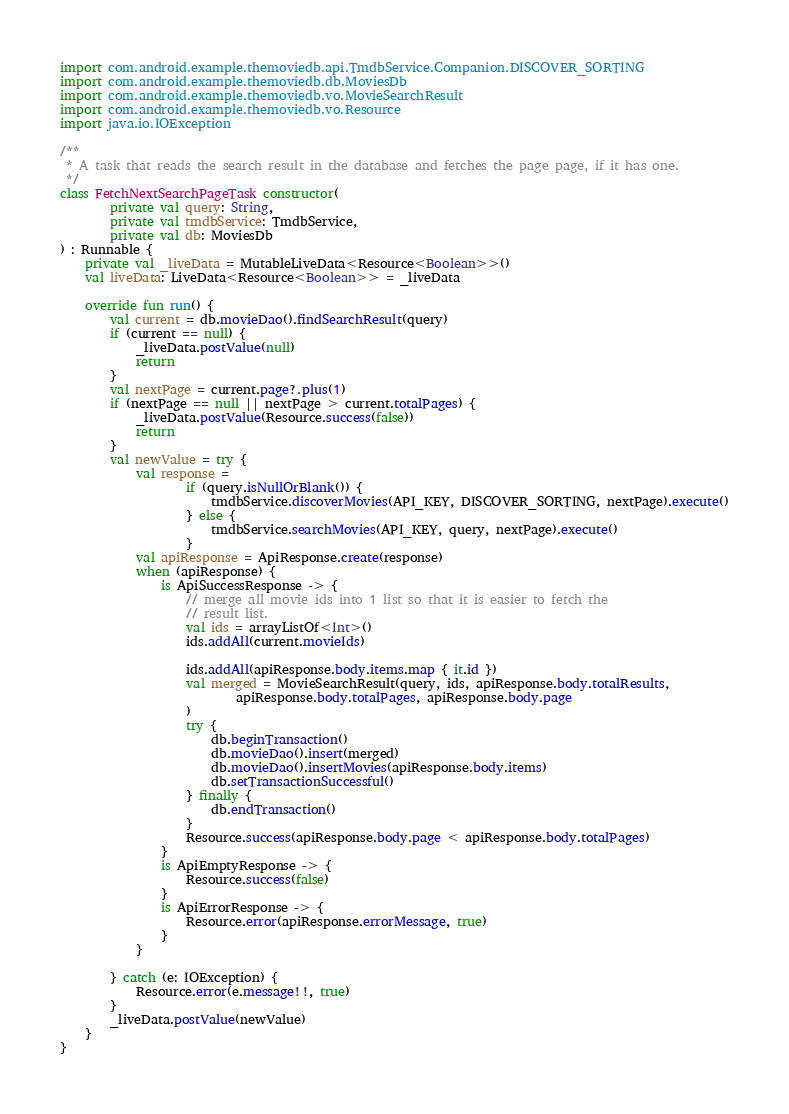Convert code to text. <code><loc_0><loc_0><loc_500><loc_500><_Kotlin_>import com.android.example.themoviedb.api.TmdbService.Companion.DISCOVER_SORTING
import com.android.example.themoviedb.db.MoviesDb
import com.android.example.themoviedb.vo.MovieSearchResult
import com.android.example.themoviedb.vo.Resource
import java.io.IOException

/**
 * A task that reads the search result in the database and fetches the page page, if it has one.
 */
class FetchNextSearchPageTask constructor(
        private val query: String,
        private val tmdbService: TmdbService,
        private val db: MoviesDb
) : Runnable {
    private val _liveData = MutableLiveData<Resource<Boolean>>()
    val liveData: LiveData<Resource<Boolean>> = _liveData

    override fun run() {
        val current = db.movieDao().findSearchResult(query)
        if (current == null) {
            _liveData.postValue(null)
            return
        }
        val nextPage = current.page?.plus(1)
        if (nextPage == null || nextPage > current.totalPages) {
            _liveData.postValue(Resource.success(false))
            return
        }
        val newValue = try {
            val response =
                    if (query.isNullOrBlank()) {
                        tmdbService.discoverMovies(API_KEY, DISCOVER_SORTING, nextPage).execute()
                    } else {
                        tmdbService.searchMovies(API_KEY, query, nextPage).execute()
                    }
            val apiResponse = ApiResponse.create(response)
            when (apiResponse) {
                is ApiSuccessResponse -> {
                    // merge all movie ids into 1 list so that it is easier to fetch the
                    // result list.
                    val ids = arrayListOf<Int>()
                    ids.addAll(current.movieIds)

                    ids.addAll(apiResponse.body.items.map { it.id })
                    val merged = MovieSearchResult(query, ids, apiResponse.body.totalResults,
                            apiResponse.body.totalPages, apiResponse.body.page
                    )
                    try {
                        db.beginTransaction()
                        db.movieDao().insert(merged)
                        db.movieDao().insertMovies(apiResponse.body.items)
                        db.setTransactionSuccessful()
                    } finally {
                        db.endTransaction()
                    }
                    Resource.success(apiResponse.body.page < apiResponse.body.totalPages)
                }
                is ApiEmptyResponse -> {
                    Resource.success(false)
                }
                is ApiErrorResponse -> {
                    Resource.error(apiResponse.errorMessage, true)
                }
            }

        } catch (e: IOException) {
            Resource.error(e.message!!, true)
        }
        _liveData.postValue(newValue)
    }
}
</code> 